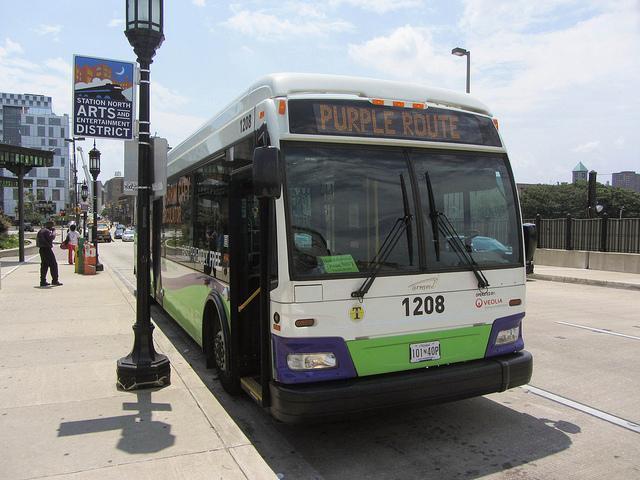What is the bus doing near the sidewalk?
Select the accurate answer and provide justification: `Answer: choice
Rationale: srationale.`
Options: Stopping, backing up, racing, accelerating. Answer: stopping.
Rationale: The bus has stopped near the sidewalk. 